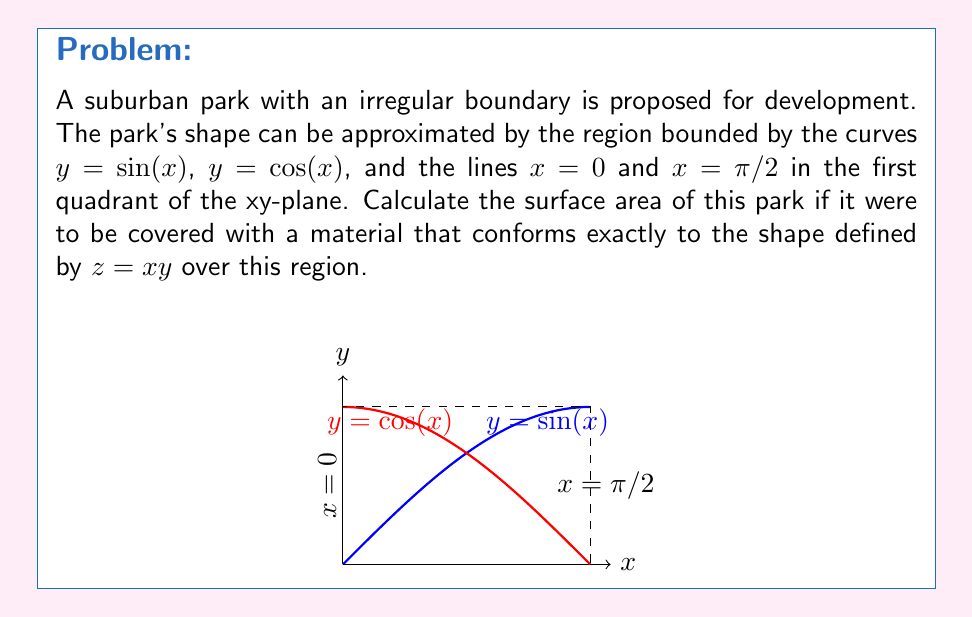Teach me how to tackle this problem. To compute the surface area, we need to use the surface integral formula:

$$SA = \int\int_R \sqrt{1 + (\frac{\partial z}{\partial x})^2 + (\frac{\partial z}{\partial y})^2} \, dA$$

Where $R$ is our region of integration.

Step 1: Find the partial derivatives
$\frac{\partial z}{\partial x} = y$ and $\frac{\partial z}{\partial y} = x$

Step 2: Set up the surface integral
$$SA = \int\int_R \sqrt{1 + y^2 + x^2} \, dA$$

Step 3: Set up the double integral with the correct bounds
The region is bounded by $y = \sin(x)$ (lower) and $y = \cos(x)$ (upper) from $x = 0$ to $x = \pi/2$

$$SA = \int_0^{\pi/2} \int_{\sin(x)}^{\cos(x)} \sqrt{1 + y^2 + x^2} \, dy \, dx$$

Step 4: This integral cannot be evaluated analytically, so we need to use numerical methods to approximate the result. Using a computer algebra system or numerical integration technique, we can approximate the integral.

Step 5: After numerical integration, we get the approximate result:
$$SA \approx 2.47 \text{ square units}$$
Answer: $2.47$ square units (approximate) 